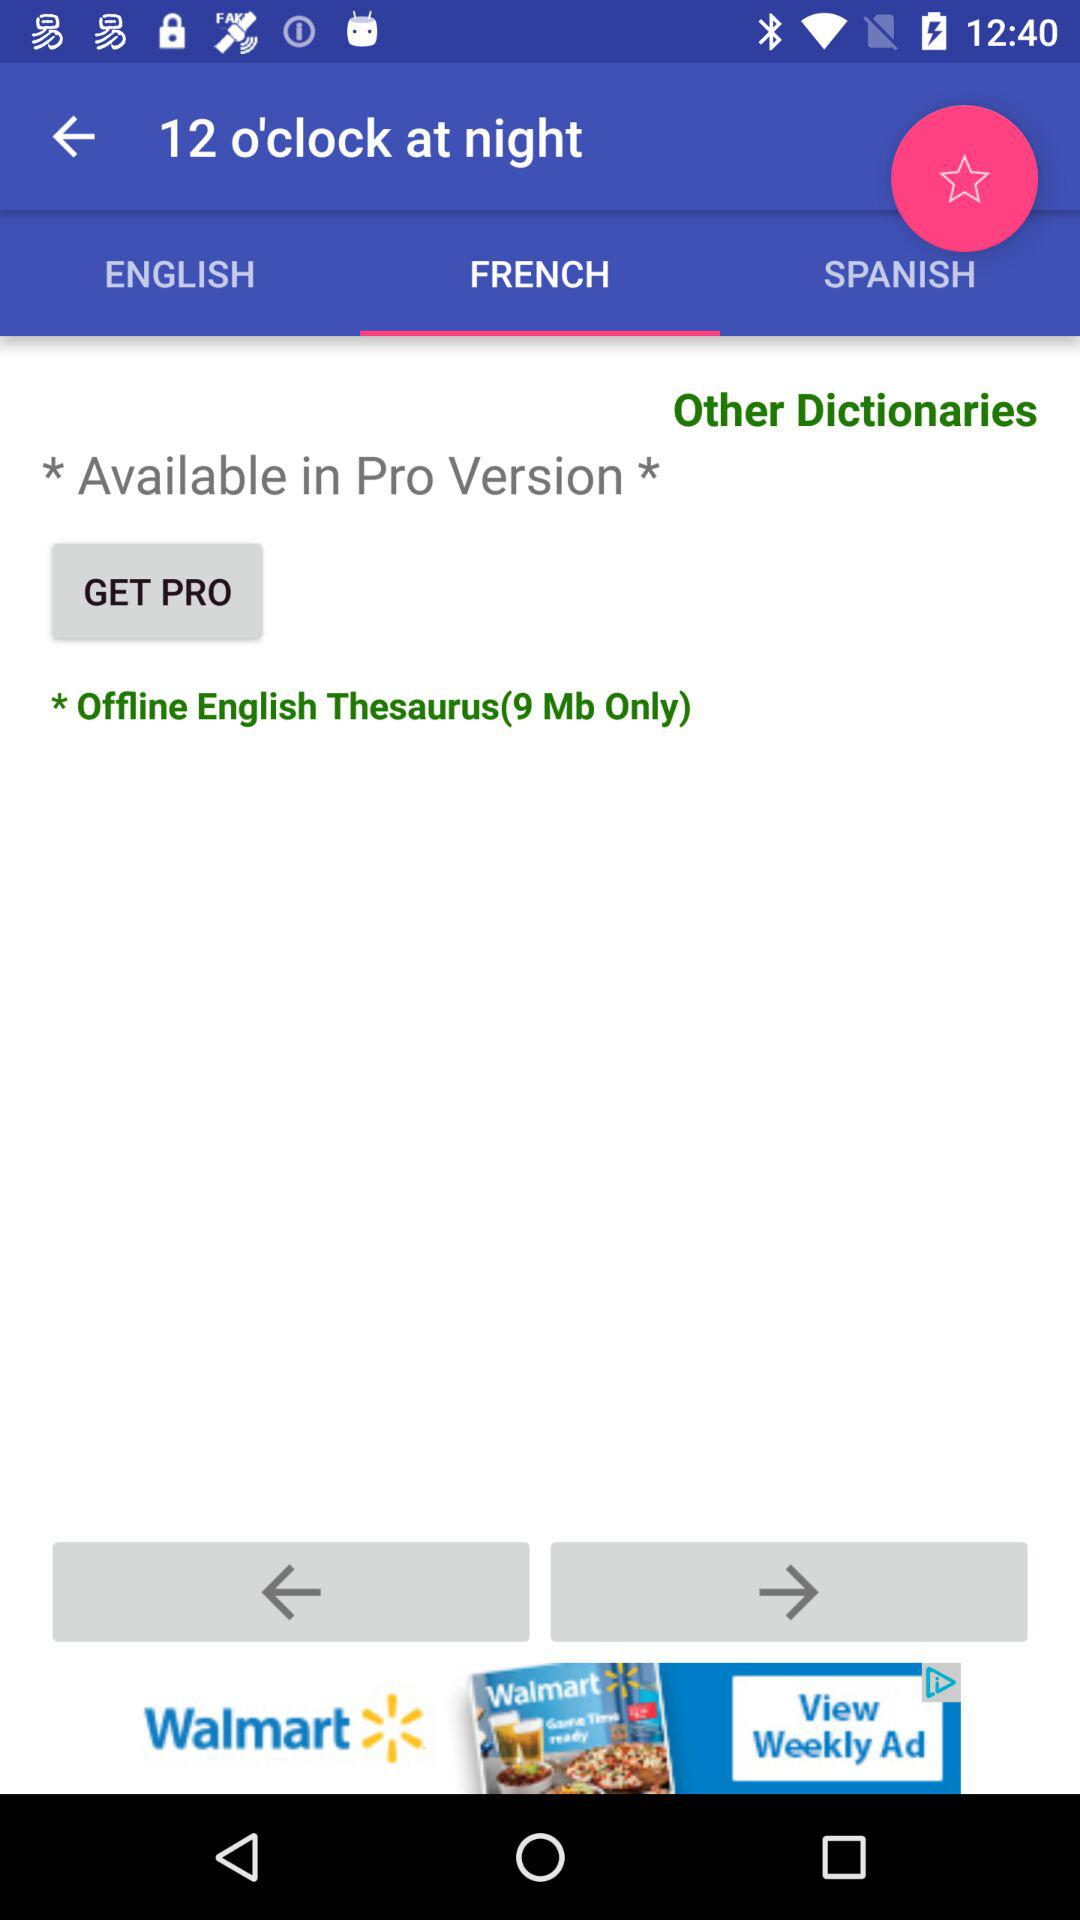How many languages are available?
Answer the question using a single word or phrase. 3 